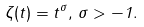<formula> <loc_0><loc_0><loc_500><loc_500>\zeta ( t ) = t ^ { \sigma } , \, \sigma > - 1 .</formula> 